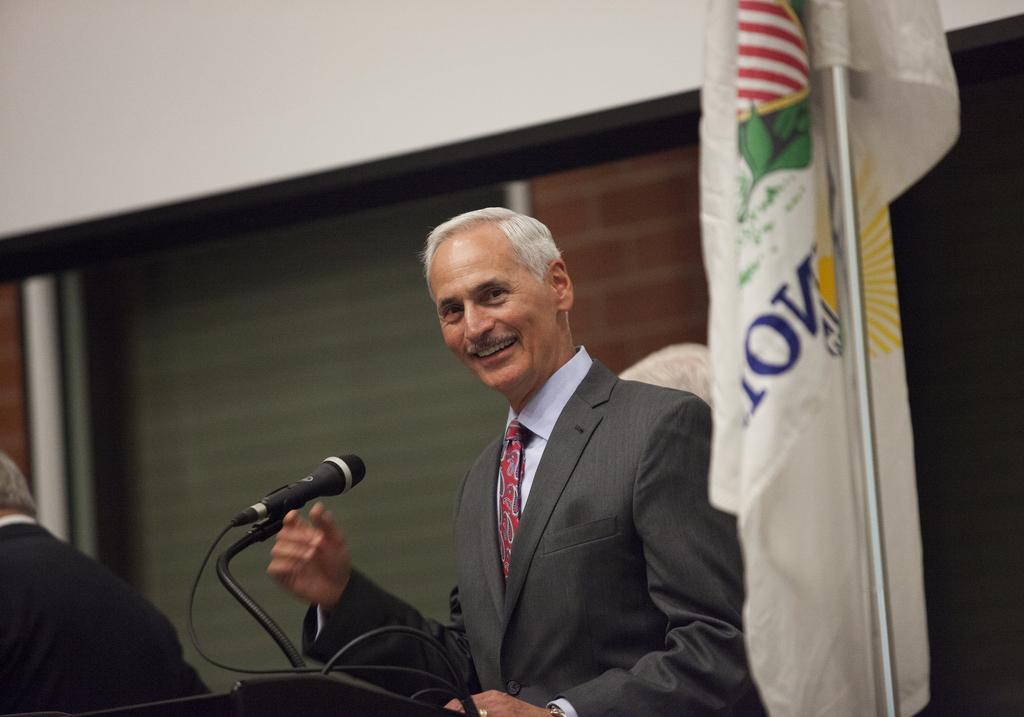What is the man in the image doing? The man is standing in the image and smiling. What object is placed in front of the man? A microphone is placed in front of the man. What can be seen in the background of the image? There are walls, windows, and a flag attached to a flag post in the background of the image. What type of trail can be seen in the image? There is no trail present in the image. How long does the man plan to rest in the image? The image does not provide information about the man's plans to rest. 